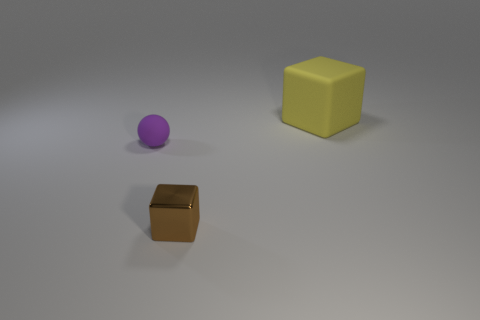There is a brown shiny object that is the same shape as the large yellow rubber object; what is its size?
Make the answer very short. Small. The rubber object left of the small brown metallic cube has what shape?
Give a very brief answer. Sphere. There is a small brown thing; is its shape the same as the object that is behind the small ball?
Offer a terse response. Yes. Are there the same number of balls behind the small purple matte sphere and big blocks to the left of the big matte cube?
Give a very brief answer. Yes. Is the color of the tiny object in front of the purple matte thing the same as the rubber thing in front of the yellow rubber block?
Provide a short and direct response. No. Is the number of brown shiny blocks that are behind the tiny rubber thing greater than the number of large matte cubes?
Your response must be concise. No. What is the material of the large thing?
Keep it short and to the point. Rubber. There is a tiny thing that is made of the same material as the big thing; what shape is it?
Ensure brevity in your answer.  Sphere. How big is the object in front of the rubber thing in front of the big matte cube?
Your response must be concise. Small. There is a cube that is in front of the large yellow matte object; what color is it?
Make the answer very short. Brown. 